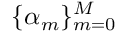<formula> <loc_0><loc_0><loc_500><loc_500>\{ \alpha _ { m } \} _ { m = 0 } ^ { M }</formula> 